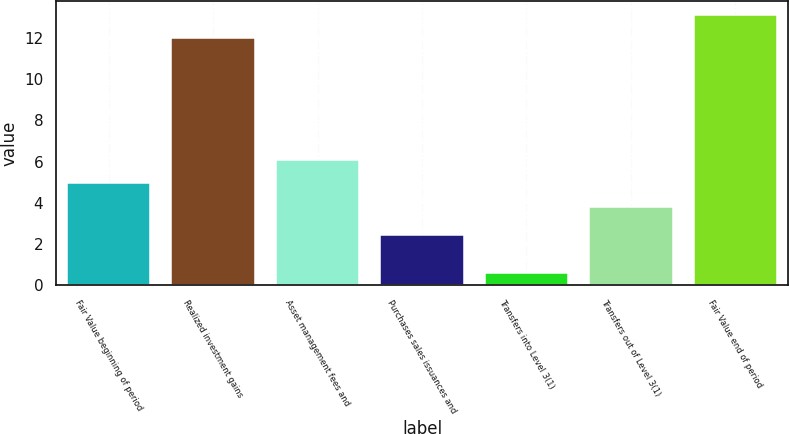Convert chart to OTSL. <chart><loc_0><loc_0><loc_500><loc_500><bar_chart><fcel>Fair Value beginning of period<fcel>Realized investment gains<fcel>Asset management fees and<fcel>Purchases sales issuances and<fcel>Transfers into Level 3(1)<fcel>Transfers out of Level 3(1)<fcel>Fair Value end of period<nl><fcel>4.94<fcel>12<fcel>6.08<fcel>2.43<fcel>0.56<fcel>3.8<fcel>13.14<nl></chart> 